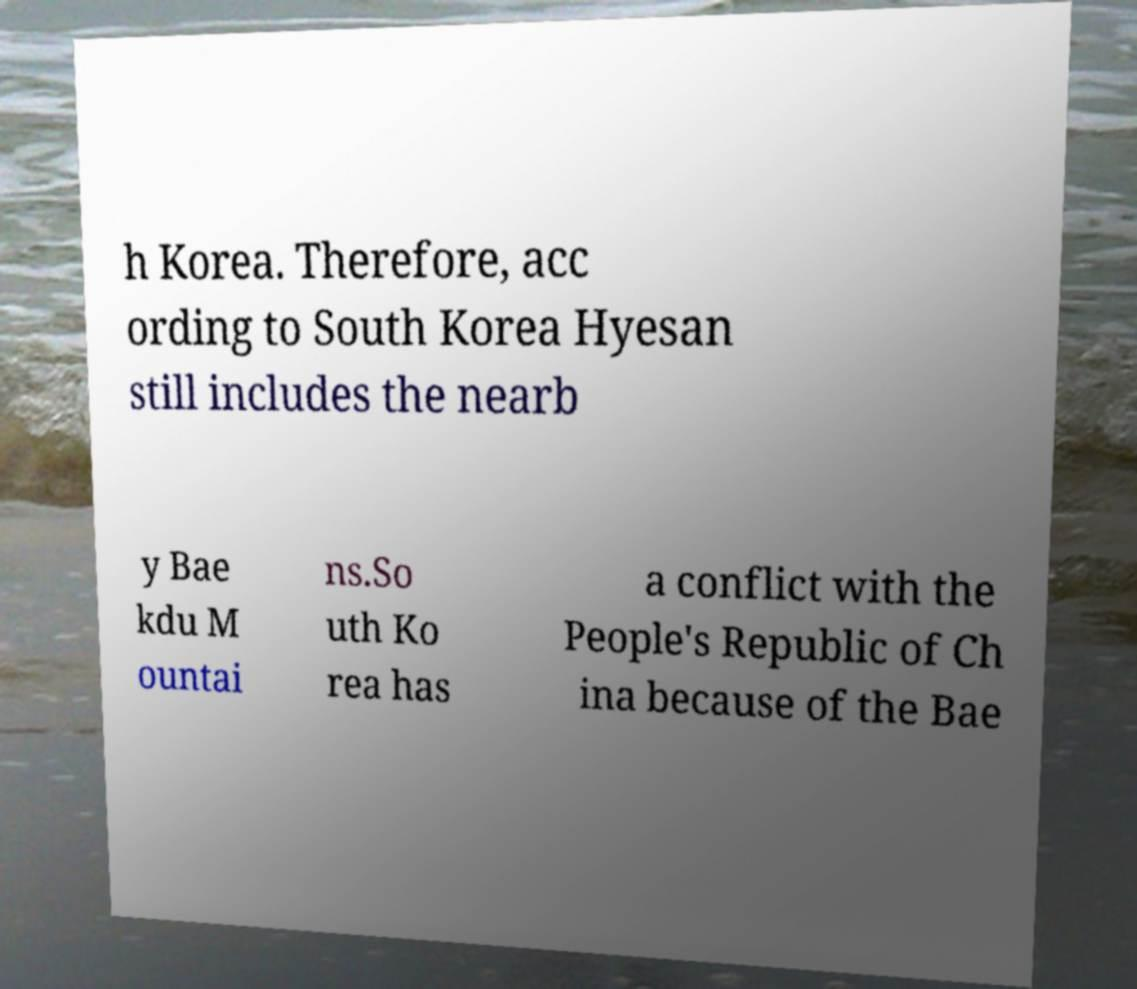Can you read and provide the text displayed in the image?This photo seems to have some interesting text. Can you extract and type it out for me? h Korea. Therefore, acc ording to South Korea Hyesan still includes the nearb y Bae kdu M ountai ns.So uth Ko rea has a conflict with the People's Republic of Ch ina because of the Bae 